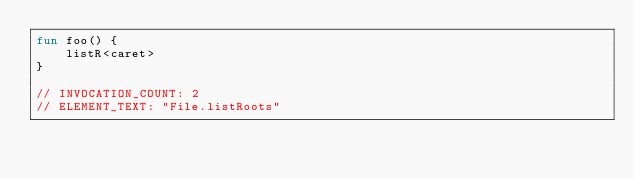<code> <loc_0><loc_0><loc_500><loc_500><_Kotlin_>fun foo() {
    listR<caret>
}

// INVOCATION_COUNT: 2
// ELEMENT_TEXT: "File.listRoots"
</code> 